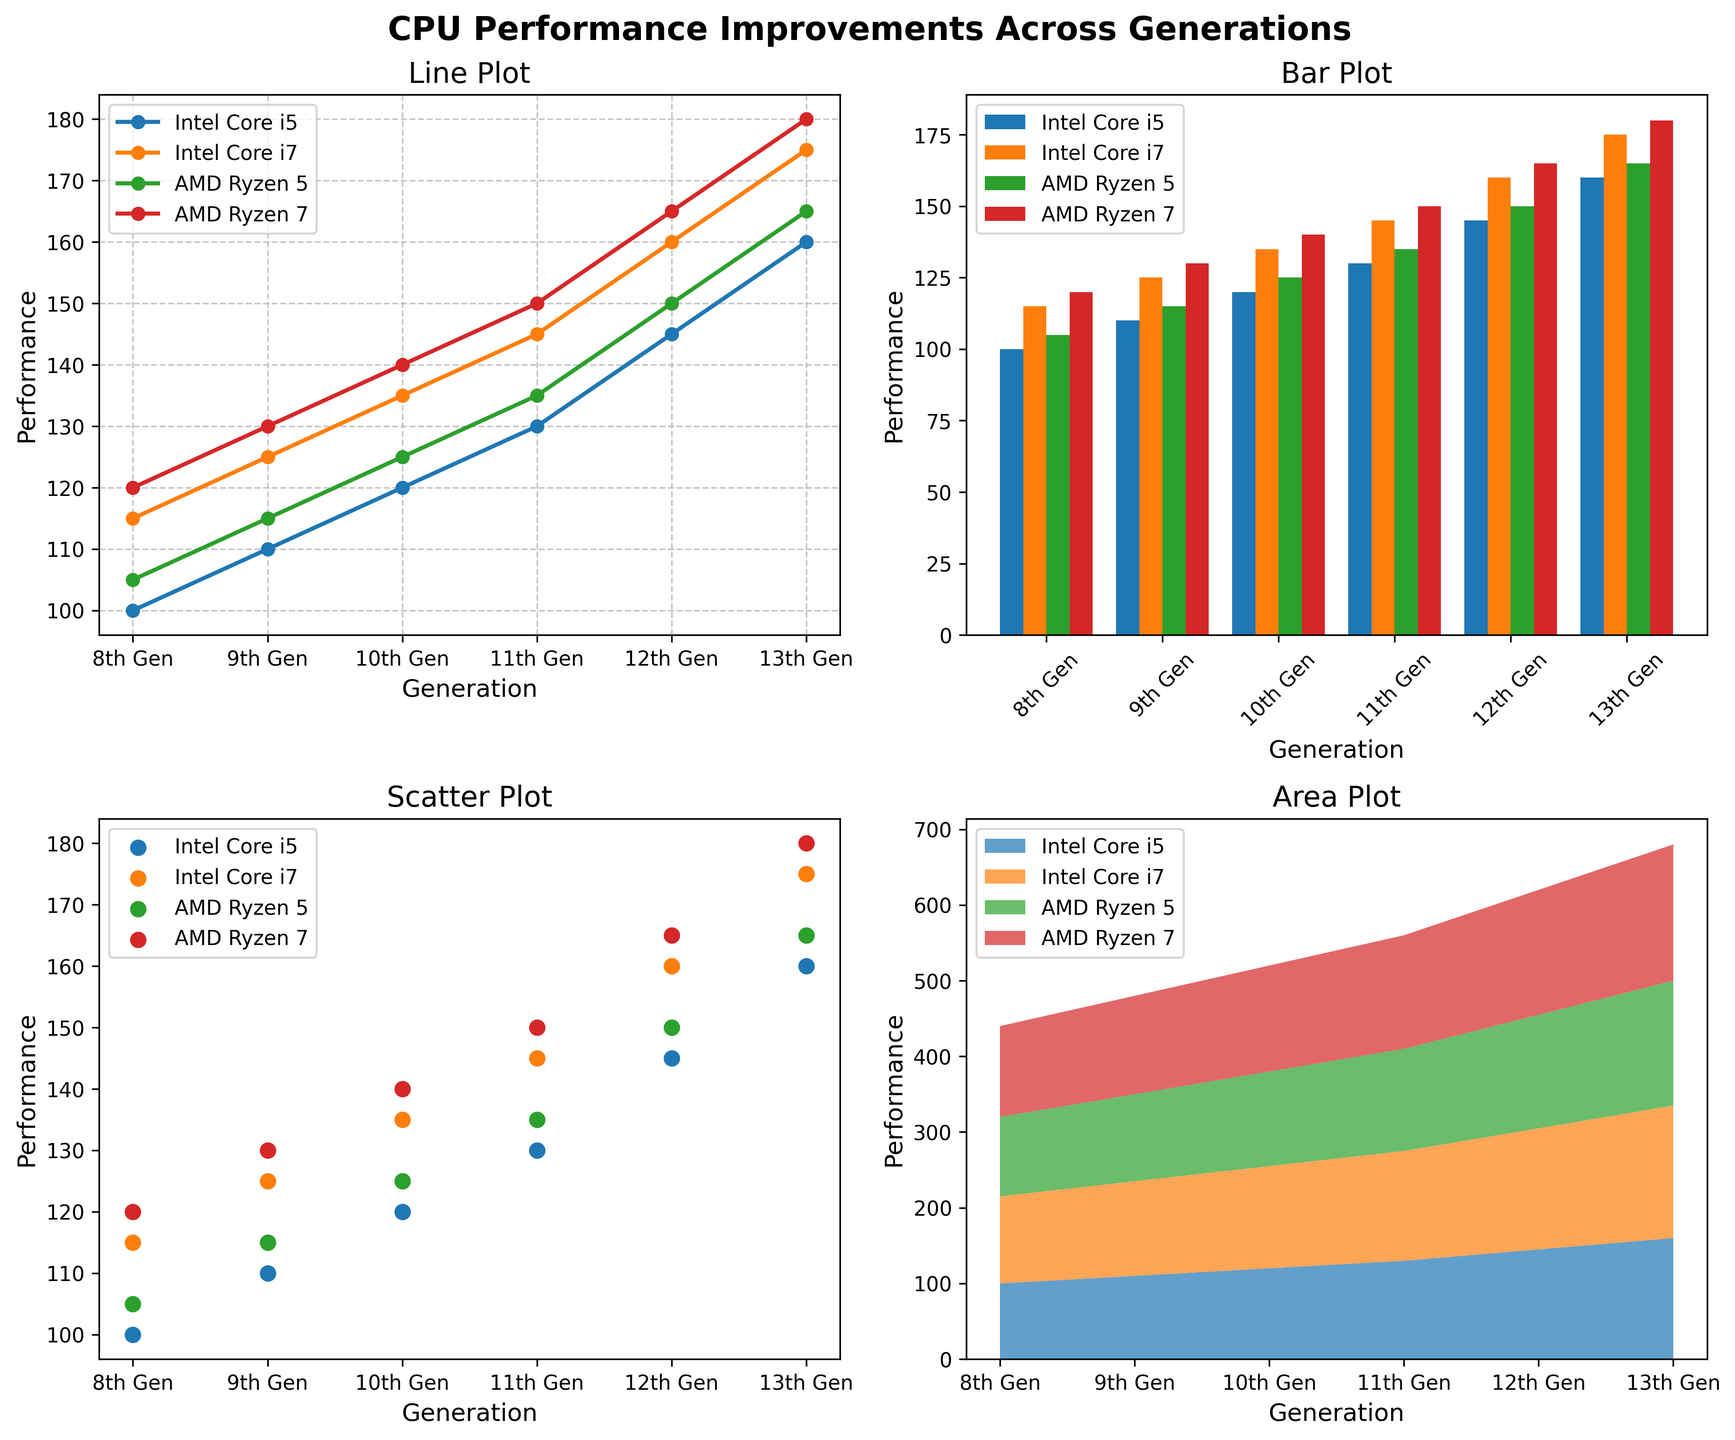What is the title of the subplot that includes lines connecting points? The title of the subplot is usually shown at the top of each subplot. The subplot that includes lines connecting points has the title "Line Plot".
Answer: Line Plot What does the y-axis represent in the Bar Plot? The y-axis label in the Bar Plot is "Performance", indicating that it represents the performance measure of the processors.
Answer: Performance How many generations of processors are compared in these plots? There are six generations listed on the x-axis of the Line Plot, Bar Plot, Scatter Plot, and Area Plot, as seen from the labels: "8th Gen", "9th Gen", "10th Gen", "11th Gen", "12th Gen", and "13th Gen".
Answer: 6 Which processor has the highest performance in the 12th generation? Looking at the data points for the 12th generation in any plot, the AMD Ryzen 7 processor has the highest value at 165.
Answer: AMD Ryzen 7 What is the performance improvement for Intel Core i5 from the 8th to the 13th generation in the Line Plot? The performance for Intel Core i5 in the 8th generation is 100 and in the 13th generation is 160. The improvement is 160 - 100 = 60.
Answer: 60 Compare the performance of Intel Core i7 and AMD Ryzen 5 in the 11th generation. Which one is better? The performance for Intel Core i7 in the 11th generation is 145, and for AMD Ryzen 5 it is 135. Since 145 > 135, Intel Core i7 is better.
Answer: Intel Core i7 What is the range of performance values for AMD Ryzen 7 shown in the Scatter Plot? The range of values for AMD Ryzen 7 can be observed by identifying the lowest and highest points in the Scatter Plot, which are 120 and 180. So, the range is 180 - 120 = 60.
Answer: 60 In the Area Plot, which processor's performance shows the most significant increase over the generations? Observing the trend lines in the Area Plot, where the shaded regions show accumulated values, it is evident that AMD Ryzen 7 shows the steepest increase in performance values.
Answer: AMD Ryzen 7 What is the overall trend of performance for Intel Core i5 over the generations in the Line Plot? From the 8th to the 13th generation, the line for Intel Core i5 consistently slopes upwards, indicating a steady increase in performance over time.
Answer: Increasing 